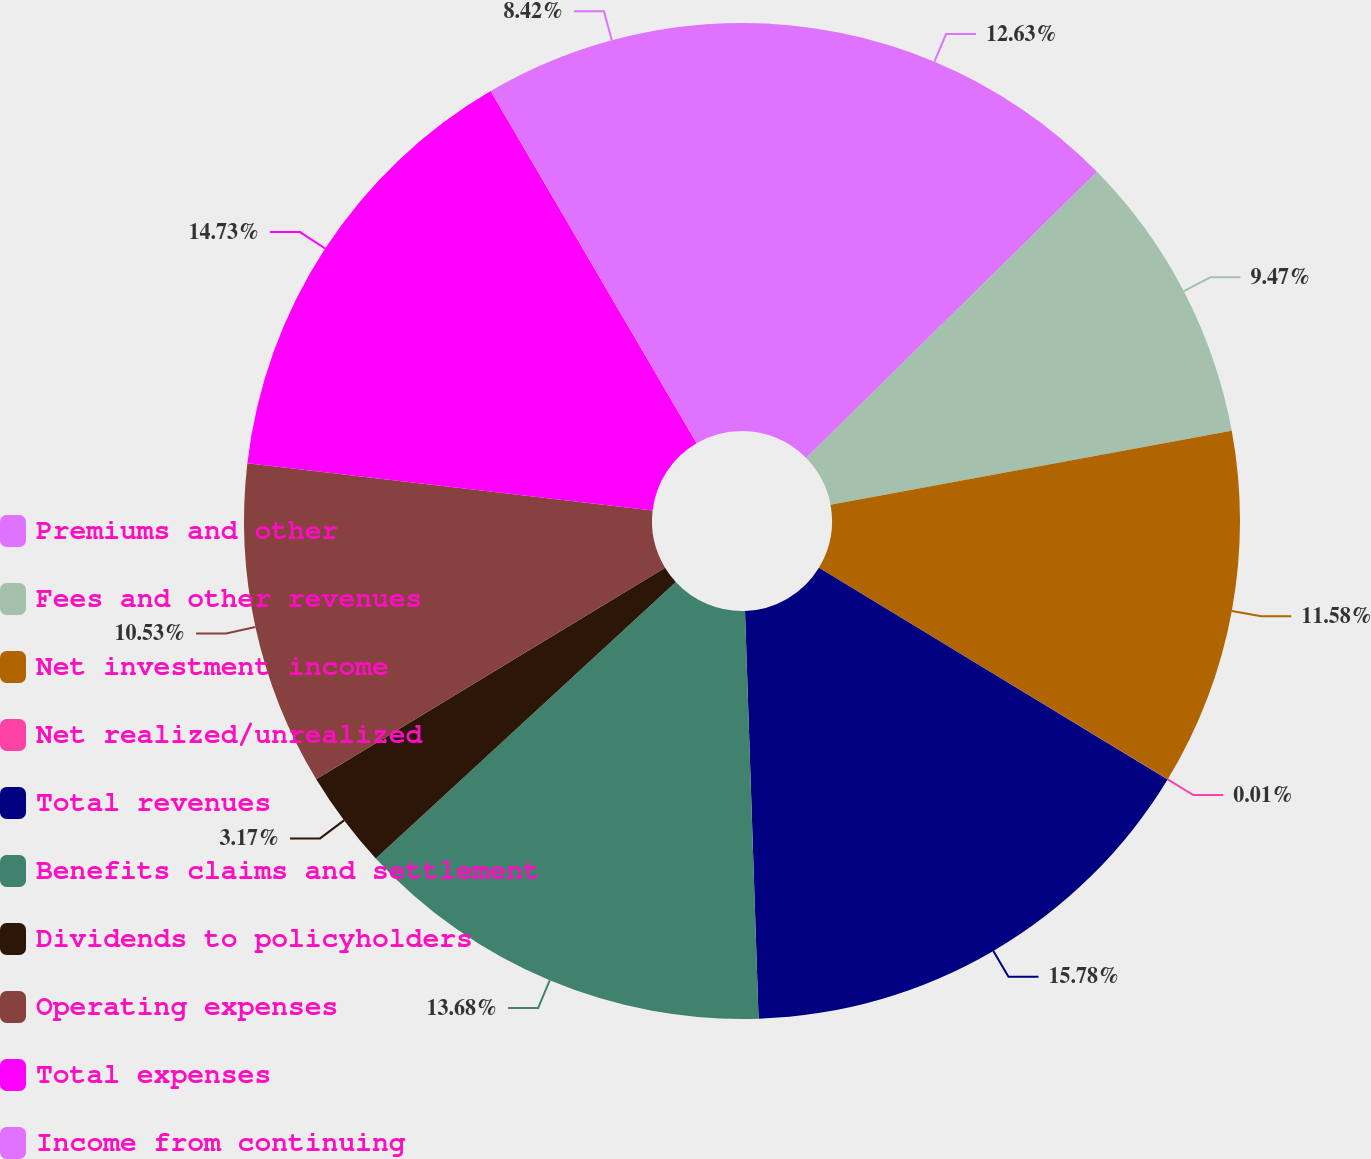Convert chart. <chart><loc_0><loc_0><loc_500><loc_500><pie_chart><fcel>Premiums and other<fcel>Fees and other revenues<fcel>Net investment income<fcel>Net realized/unrealized<fcel>Total revenues<fcel>Benefits claims and settlement<fcel>Dividends to policyholders<fcel>Operating expenses<fcel>Total expenses<fcel>Income from continuing<nl><fcel>12.63%<fcel>9.47%<fcel>11.58%<fcel>0.01%<fcel>15.78%<fcel>13.68%<fcel>3.17%<fcel>10.53%<fcel>14.73%<fcel>8.42%<nl></chart> 